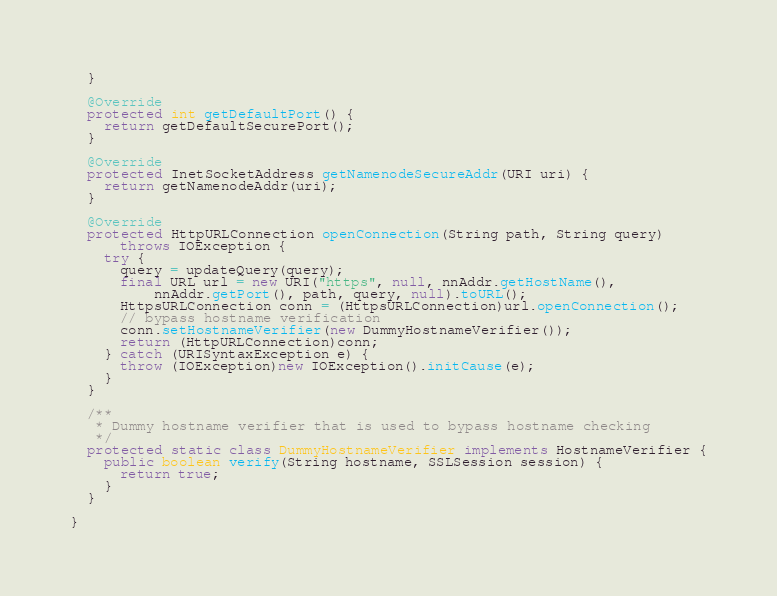Convert code to text. <code><loc_0><loc_0><loc_500><loc_500><_Java_>  }

  @Override
  protected int getDefaultPort() {
    return getDefaultSecurePort();
  }

  @Override
  protected InetSocketAddress getNamenodeSecureAddr(URI uri) {
    return getNamenodeAddr(uri);
  }

  @Override
  protected HttpURLConnection openConnection(String path, String query)
      throws IOException {
    try {
      query = updateQuery(query);
      final URL url = new URI("https", null, nnAddr.getHostName(),
          nnAddr.getPort(), path, query, null).toURL();
      HttpsURLConnection conn = (HttpsURLConnection)url.openConnection();
      // bypass hostname verification
      conn.setHostnameVerifier(new DummyHostnameVerifier());
      return (HttpURLConnection)conn;
    } catch (URISyntaxException e) {
      throw (IOException)new IOException().initCause(e);
    }
  }

  /**
   * Dummy hostname verifier that is used to bypass hostname checking
   */
  protected static class DummyHostnameVerifier implements HostnameVerifier {
    public boolean verify(String hostname, SSLSession session) {
      return true;
    }
  }

}
</code> 